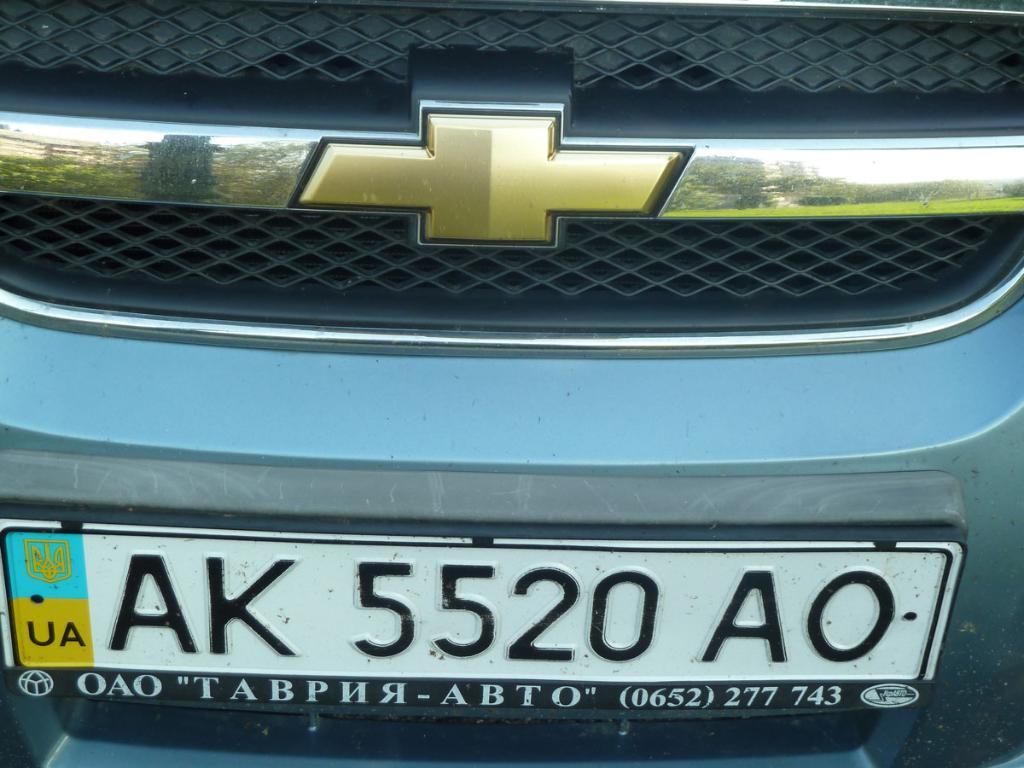What is the license plate number?
Give a very brief answer. Ak 5520 ao. 